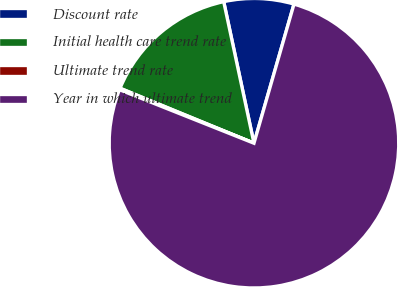Convert chart to OTSL. <chart><loc_0><loc_0><loc_500><loc_500><pie_chart><fcel>Discount rate<fcel>Initial health care trend rate<fcel>Ultimate trend rate<fcel>Year in which ultimate trend<nl><fcel>7.81%<fcel>15.45%<fcel>0.17%<fcel>76.57%<nl></chart> 